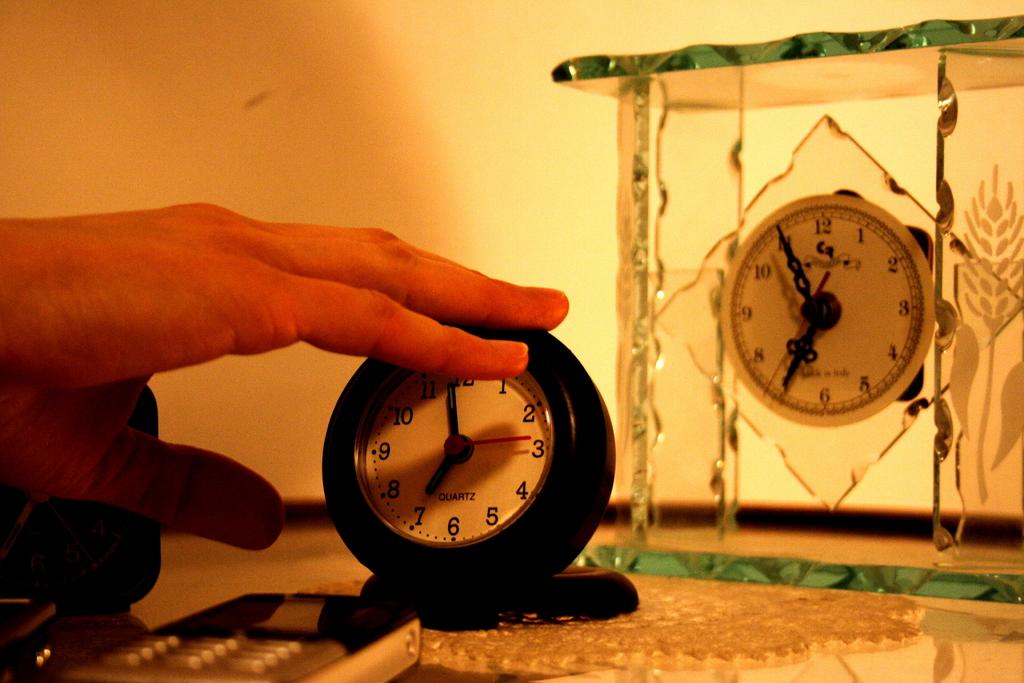<image>
Describe the image concisely. a clock that has 1 to 12 on the front 